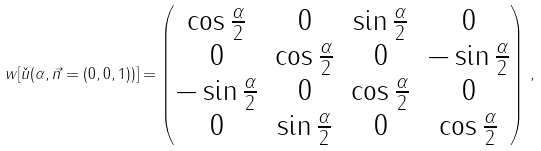<formula> <loc_0><loc_0><loc_500><loc_500>w [ \check { u } ( \alpha , \vec { n } = ( 0 , 0 , 1 ) ) ] = \begin{pmatrix} \cos \frac { \alpha } { 2 } & 0 & \sin \frac { \alpha } { 2 } & 0 \\ 0 & \cos \frac { \alpha } { 2 } & 0 & - \sin \frac { \alpha } { 2 } \\ - \sin \frac { \alpha } { 2 } & 0 & \cos \frac { \alpha } { 2 } & 0 \\ 0 & \sin \frac { \alpha } { 2 } & 0 & \cos \frac { \alpha } { 2 } \end{pmatrix} \, ,</formula> 